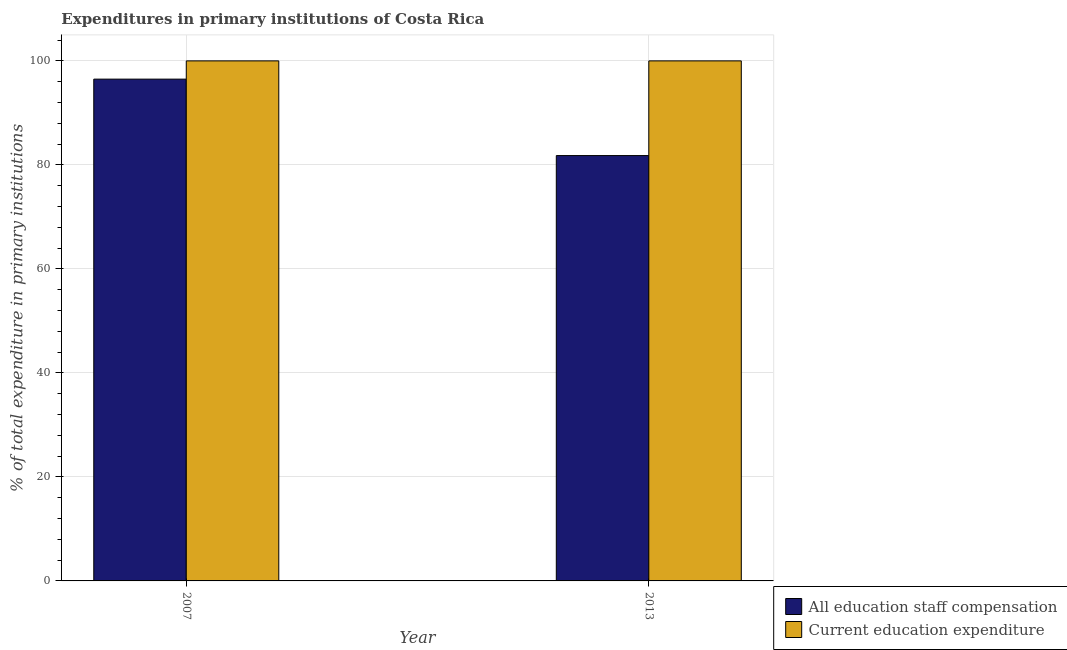How many groups of bars are there?
Offer a terse response. 2. How many bars are there on the 1st tick from the left?
Your response must be concise. 2. How many bars are there on the 2nd tick from the right?
Offer a terse response. 2. What is the label of the 2nd group of bars from the left?
Make the answer very short. 2013. What is the expenditure in staff compensation in 2007?
Your response must be concise. 96.49. Across all years, what is the maximum expenditure in staff compensation?
Your response must be concise. 96.49. Across all years, what is the minimum expenditure in education?
Your response must be concise. 100. In which year was the expenditure in staff compensation minimum?
Offer a terse response. 2013. What is the total expenditure in staff compensation in the graph?
Keep it short and to the point. 178.28. What is the difference between the expenditure in staff compensation in 2007 and that in 2013?
Give a very brief answer. 14.7. What is the difference between the expenditure in staff compensation in 2013 and the expenditure in education in 2007?
Keep it short and to the point. -14.7. In the year 2007, what is the difference between the expenditure in education and expenditure in staff compensation?
Ensure brevity in your answer.  0. In how many years, is the expenditure in education greater than the average expenditure in education taken over all years?
Provide a succinct answer. 0. What does the 2nd bar from the left in 2013 represents?
Provide a short and direct response. Current education expenditure. What does the 2nd bar from the right in 2007 represents?
Offer a very short reply. All education staff compensation. How many bars are there?
Provide a succinct answer. 4. Are all the bars in the graph horizontal?
Provide a succinct answer. No. What is the difference between two consecutive major ticks on the Y-axis?
Make the answer very short. 20. Does the graph contain grids?
Your response must be concise. Yes. How many legend labels are there?
Ensure brevity in your answer.  2. How are the legend labels stacked?
Give a very brief answer. Vertical. What is the title of the graph?
Your answer should be compact. Expenditures in primary institutions of Costa Rica. What is the label or title of the Y-axis?
Your answer should be compact. % of total expenditure in primary institutions. What is the % of total expenditure in primary institutions of All education staff compensation in 2007?
Keep it short and to the point. 96.49. What is the % of total expenditure in primary institutions of Current education expenditure in 2007?
Offer a very short reply. 100. What is the % of total expenditure in primary institutions in All education staff compensation in 2013?
Give a very brief answer. 81.79. What is the % of total expenditure in primary institutions in Current education expenditure in 2013?
Keep it short and to the point. 100. Across all years, what is the maximum % of total expenditure in primary institutions of All education staff compensation?
Your answer should be very brief. 96.49. Across all years, what is the minimum % of total expenditure in primary institutions in All education staff compensation?
Offer a very short reply. 81.79. What is the total % of total expenditure in primary institutions in All education staff compensation in the graph?
Make the answer very short. 178.28. What is the total % of total expenditure in primary institutions of Current education expenditure in the graph?
Provide a short and direct response. 200. What is the difference between the % of total expenditure in primary institutions in All education staff compensation in 2007 and that in 2013?
Your response must be concise. 14.7. What is the difference between the % of total expenditure in primary institutions in Current education expenditure in 2007 and that in 2013?
Offer a terse response. 0. What is the difference between the % of total expenditure in primary institutions of All education staff compensation in 2007 and the % of total expenditure in primary institutions of Current education expenditure in 2013?
Your response must be concise. -3.51. What is the average % of total expenditure in primary institutions of All education staff compensation per year?
Make the answer very short. 89.14. What is the average % of total expenditure in primary institutions of Current education expenditure per year?
Your answer should be compact. 100. In the year 2007, what is the difference between the % of total expenditure in primary institutions in All education staff compensation and % of total expenditure in primary institutions in Current education expenditure?
Give a very brief answer. -3.51. In the year 2013, what is the difference between the % of total expenditure in primary institutions of All education staff compensation and % of total expenditure in primary institutions of Current education expenditure?
Offer a terse response. -18.21. What is the ratio of the % of total expenditure in primary institutions of All education staff compensation in 2007 to that in 2013?
Offer a very short reply. 1.18. What is the difference between the highest and the second highest % of total expenditure in primary institutions in All education staff compensation?
Provide a short and direct response. 14.7. What is the difference between the highest and the second highest % of total expenditure in primary institutions of Current education expenditure?
Provide a short and direct response. 0. What is the difference between the highest and the lowest % of total expenditure in primary institutions in All education staff compensation?
Your answer should be very brief. 14.7. What is the difference between the highest and the lowest % of total expenditure in primary institutions in Current education expenditure?
Offer a terse response. 0. 